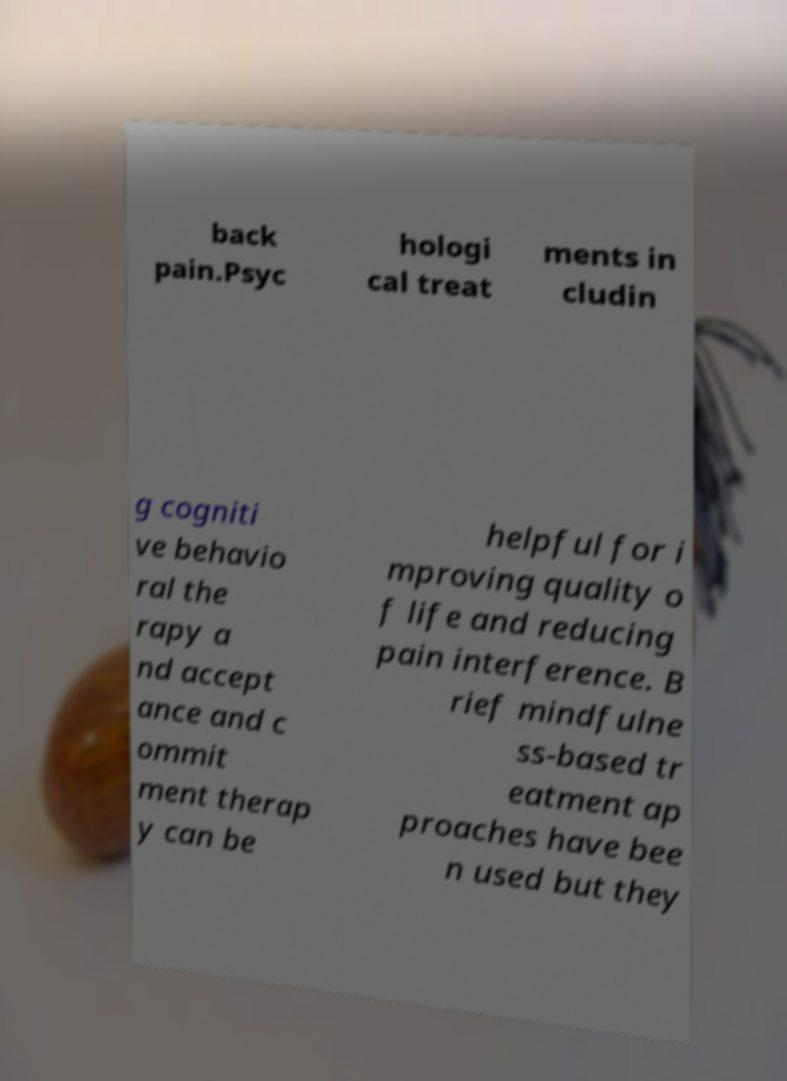What messages or text are displayed in this image? I need them in a readable, typed format. back pain.Psyc hologi cal treat ments in cludin g cogniti ve behavio ral the rapy a nd accept ance and c ommit ment therap y can be helpful for i mproving quality o f life and reducing pain interference. B rief mindfulne ss-based tr eatment ap proaches have bee n used but they 